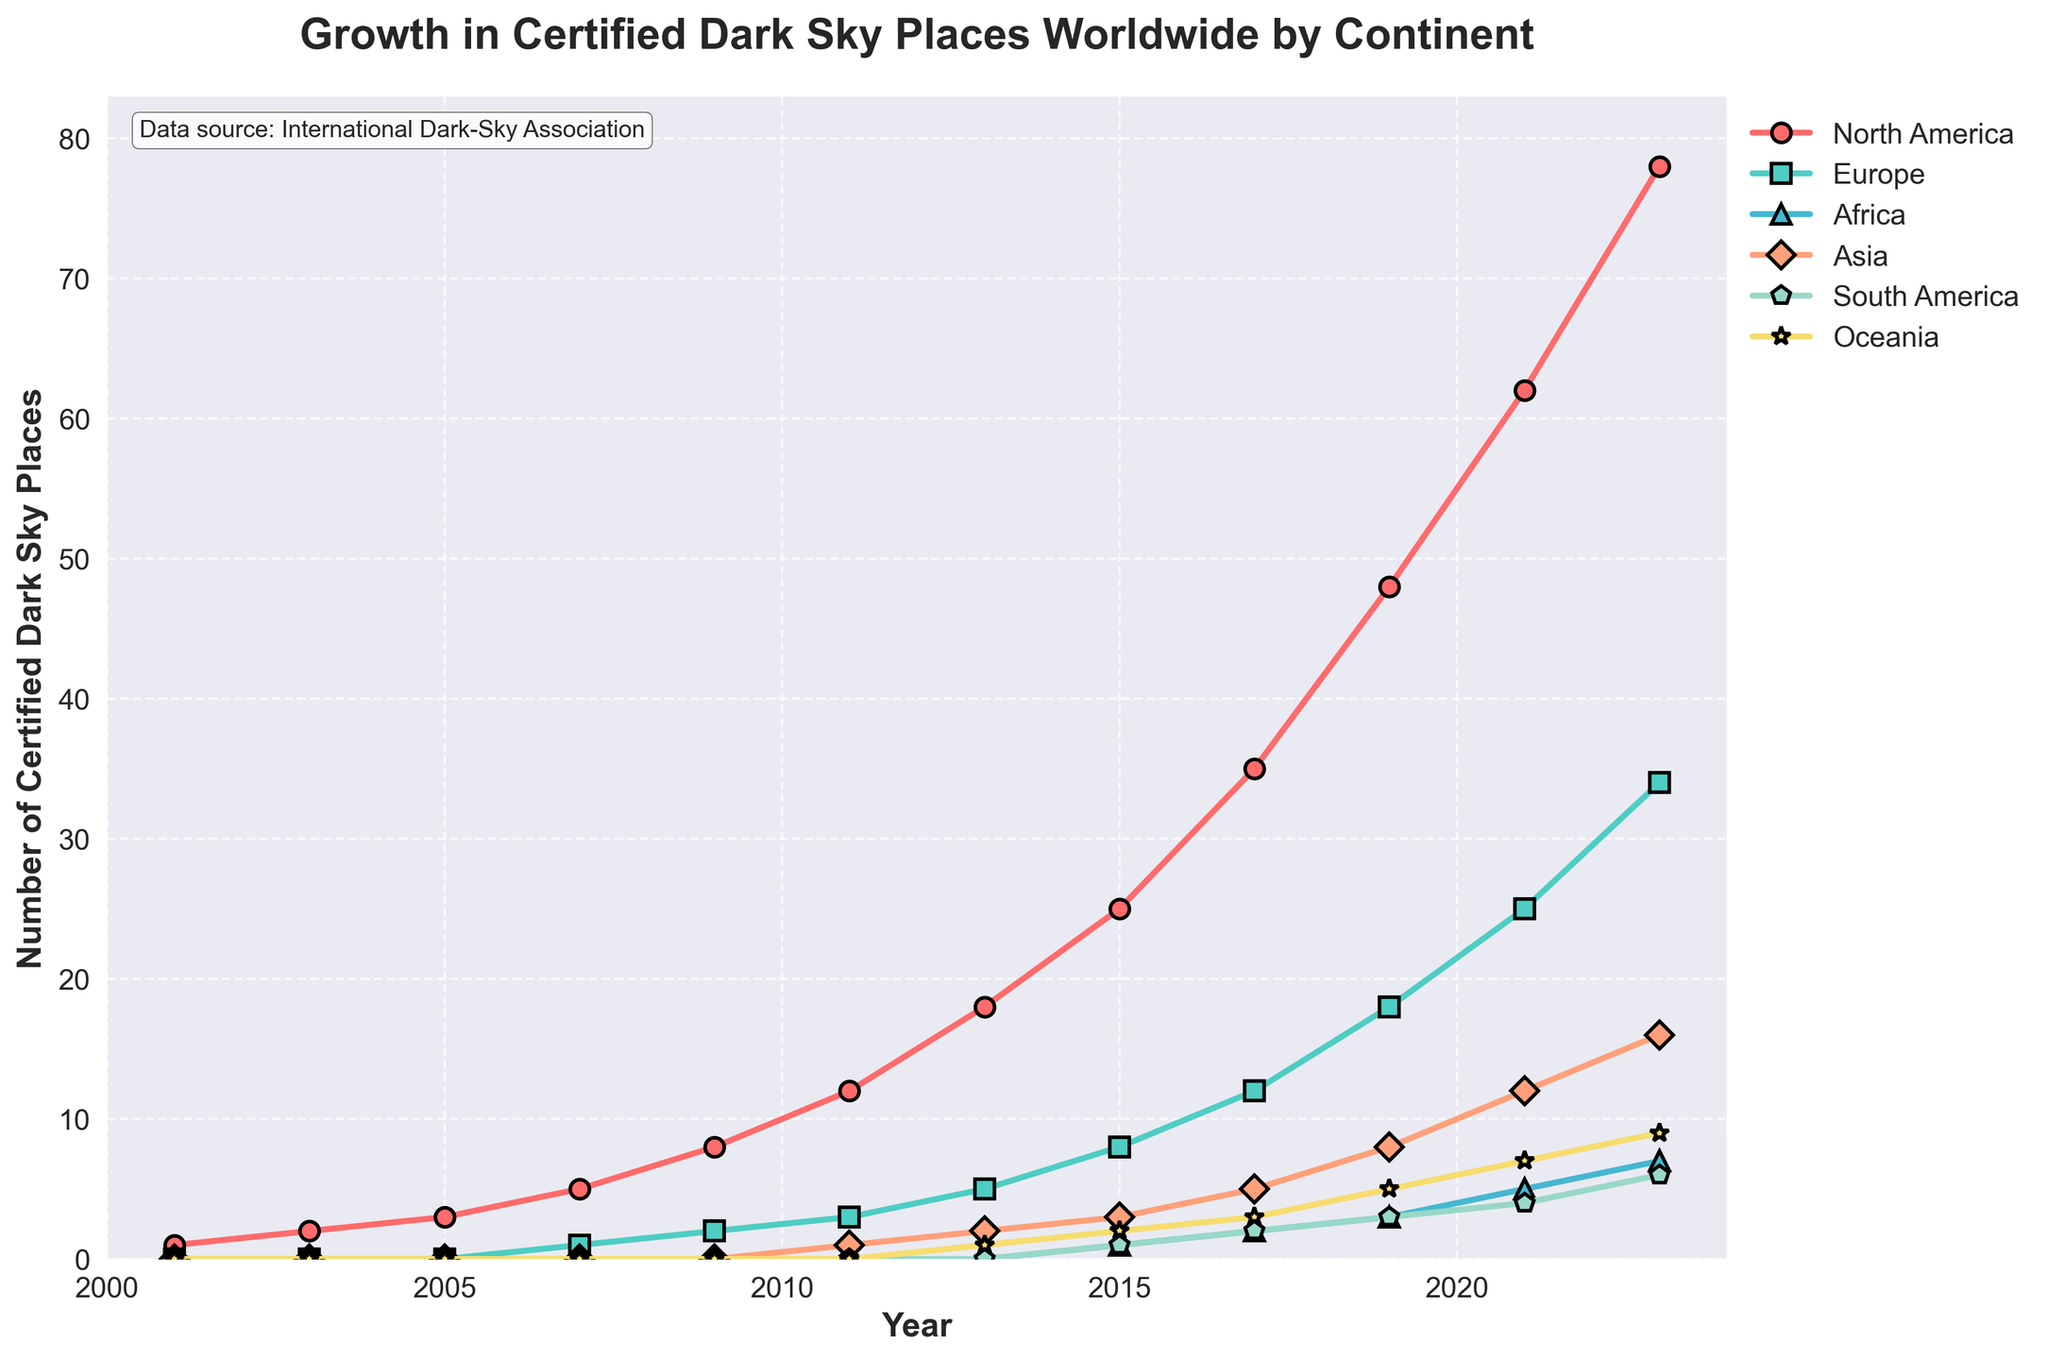What's the total number of certified dark sky places across all continents in 2023? To find the total number, sum the values for all continents in 2023: 78 (North America) + 34 (Europe) + 7 (Africa) + 16 (Asia) + 6 (South America) + 9 (Oceania) = 150.
Answer: 150 Which continent had the highest growth in the number of certified dark sky places from 2001 to 2023? Calculate the difference for each continent between 2023 and 2001 values. North America: 78 - 1 = 77, Europe: 34 - 0 = 34; the highest difference is for North America with a growth of 77.
Answer: North America How many more certified dark sky places did North America have compared to Europe in 2021? Difference between North America's and Europe's values in 2021: 62 (North America) - 25 (Europe) = 37.
Answer: 37 By how many certified dark sky places did Oceania increase from 2011 to 2023? Calculate the difference between 2023 and 2011 values for Oceania: 9 (2023) - 0 (2011) = 9.
Answer: 9 Which continent had the least number of certified dark sky places in 2017? In 2017, the values are: North America (35), Europe (12), Africa (2), Asia (5), South America (2), Oceania (3). The least number is 2 (Africa and South America).
Answer: Africa, South America What's the average number of certified dark sky places in Asia over the years 2011, 2013, and 2015? Sum the values for Asia in 2011, 2013, and 2015 and divide by 3: (1 + 2 + 3)/3 = 6/3 = 2.
Answer: 2 Did any continent show a decrease in the number of certified dark sky places at any point from 2001 to 2023? Examine each time interval; all continents show either increase or no change in each step, hence no continent shows a decrease.
Answer: No Among all continents, which had the second-highest number of certified dark sky places in 2023? Reviewing 2023 values: North America (78), Europe (34), Africa (7), Asia (16), South America (6), Oceania (9); the second highest is Europe with 34.
Answer: Europe How many certified dark sky places did Africa gain between 2015 and 2019? Difference between Africa's values for 2019 and 2015: 3 (2019) - 1 (2015) = 2.
Answer: 2 